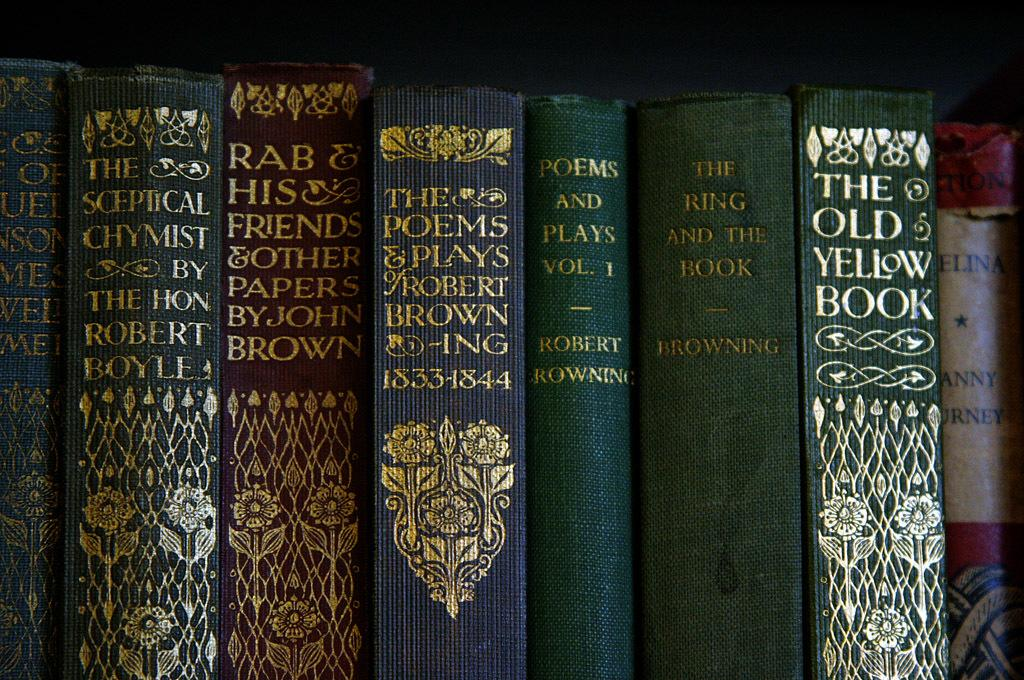<image>
Create a compact narrative representing the image presented. A collection of books on a shelf, including one of John Brown. 